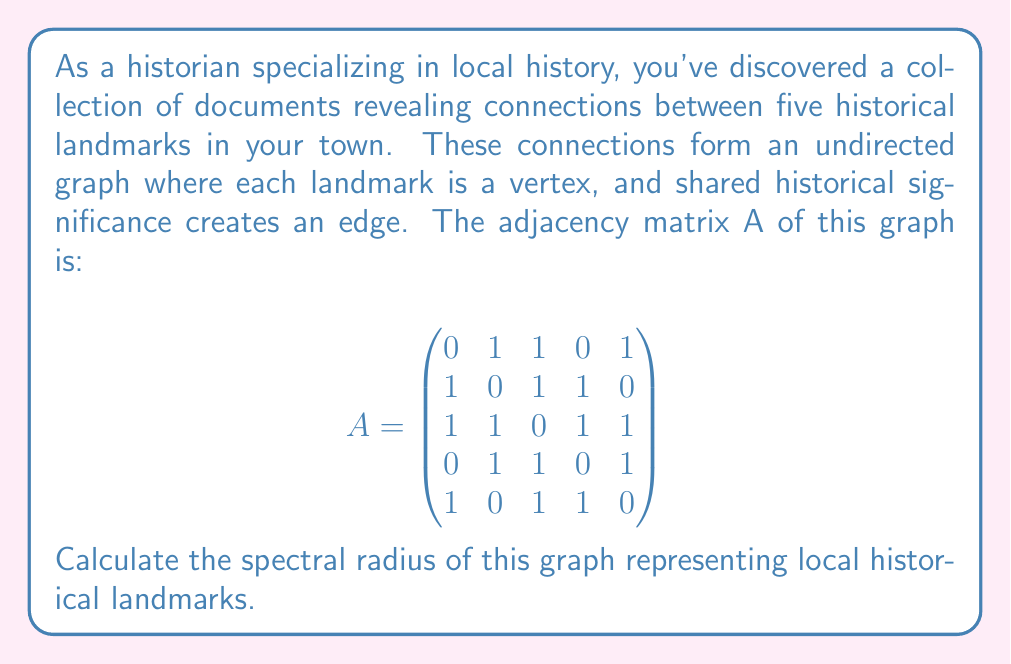Provide a solution to this math problem. To find the spectral radius of the graph, we need to follow these steps:

1) The spectral radius is the largest absolute eigenvalue of the adjacency matrix A.

2) To find the eigenvalues, we need to solve the characteristic equation:
   $$\det(A - \lambda I) = 0$$
   where I is the 5x5 identity matrix and λ represents the eigenvalues.

3) Expanding this determinant:
   $$\begin{vmatrix}
   -\lambda & 1 & 1 & 0 & 1\\
   1 & -\lambda & 1 & 1 & 0\\
   1 & 1 & -\lambda & 1 & 1\\
   0 & 1 & 1 & -\lambda & 1\\
   1 & 0 & 1 & 1 & -\lambda
   \end{vmatrix} = 0$$

4) This expands to the characteristic polynomial:
   $$\lambda^5 - 10\lambda^3 - 8\lambda^2 + 5\lambda + 4 = 0$$

5) While solving this polynomial analytically is complex, we can use numerical methods or computer algebra systems to find its roots.

6) The roots (eigenvalues) of this polynomial are approximately:
   $$\lambda_1 \approx 2.5616$$
   $$\lambda_2 \approx -1.7321$$
   $$\lambda_3 \approx 0.7889$$
   $$\lambda_4 \approx -0.8184$$
   $$\lambda_5 \approx 0.2000$$

7) The spectral radius is the largest absolute value among these eigenvalues, which is $|\lambda_1| \approx 2.5616$.
Answer: $2.5616$ 